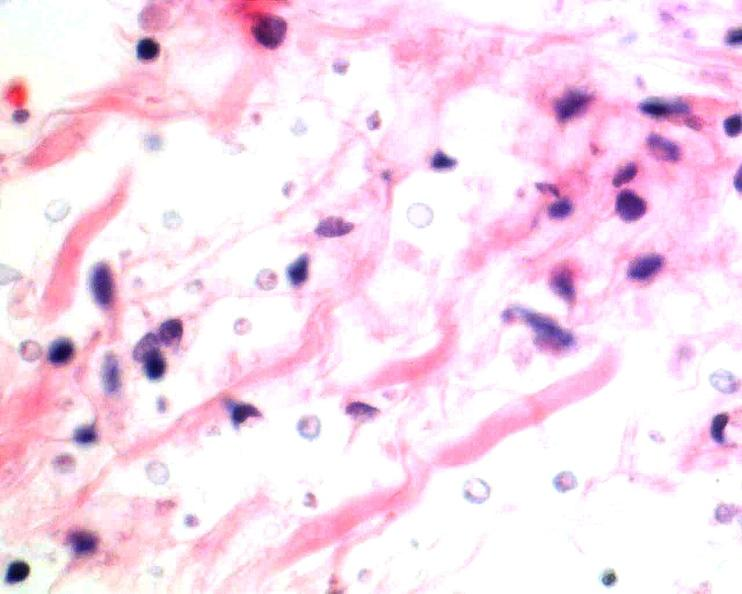what does this image show?
Answer the question using a single word or phrase. Brain 